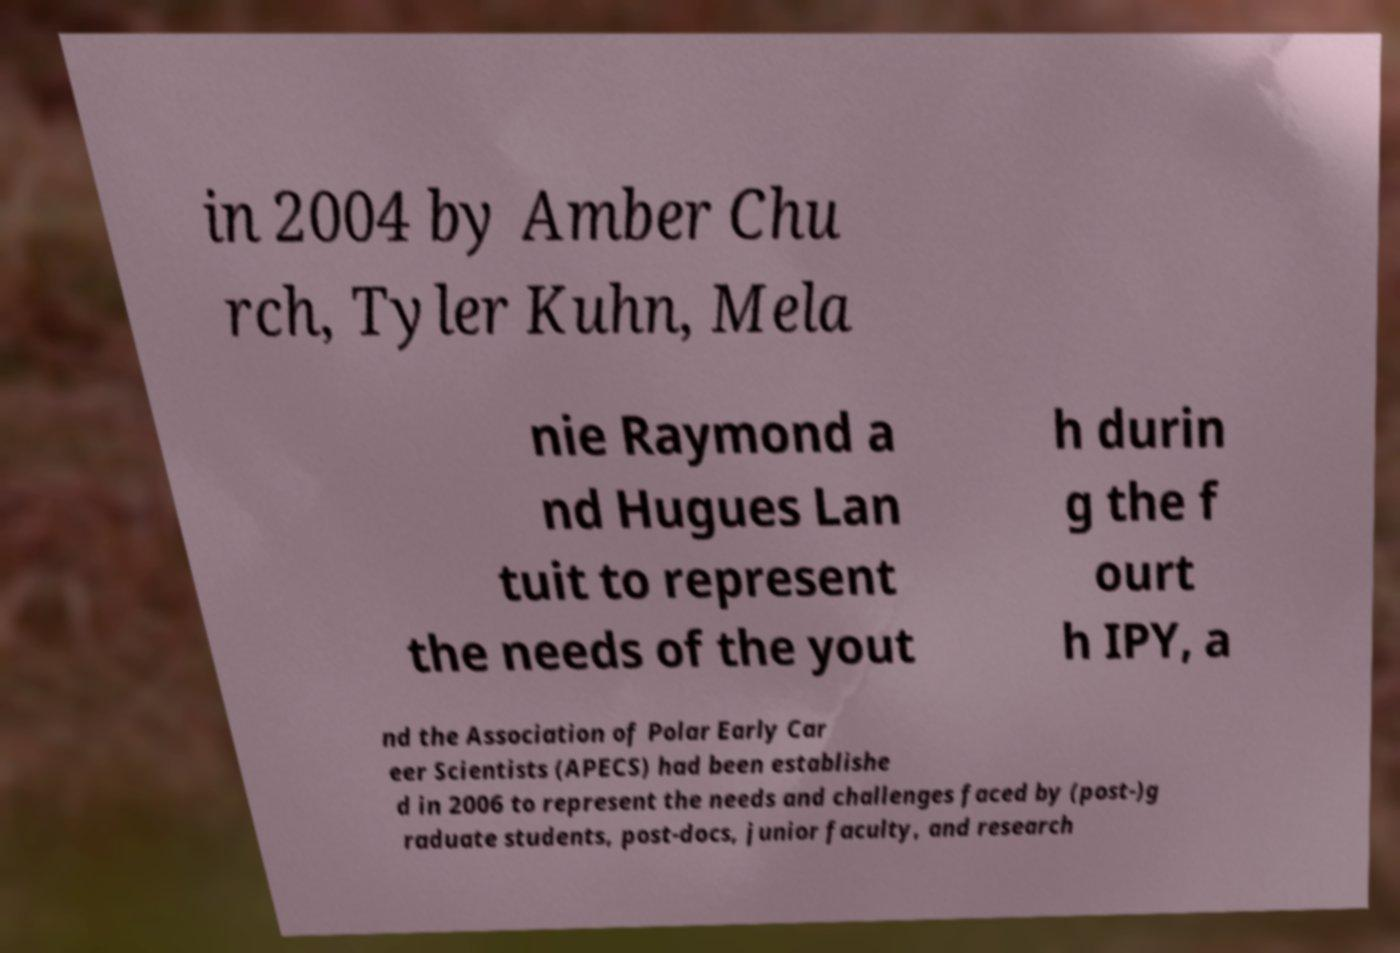Can you accurately transcribe the text from the provided image for me? in 2004 by Amber Chu rch, Tyler Kuhn, Mela nie Raymond a nd Hugues Lan tuit to represent the needs of the yout h durin g the f ourt h IPY, a nd the Association of Polar Early Car eer Scientists (APECS) had been establishe d in 2006 to represent the needs and challenges faced by (post-)g raduate students, post-docs, junior faculty, and research 